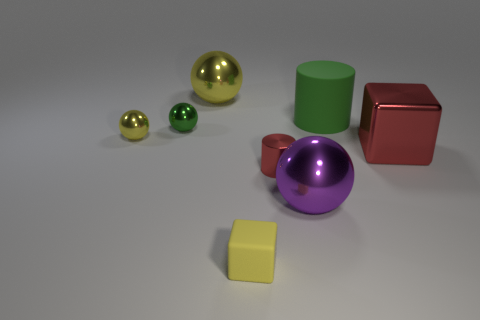Subtract 1 balls. How many balls are left? 3 Add 2 red metal objects. How many objects exist? 10 Subtract all blocks. How many objects are left? 6 Add 5 purple objects. How many purple objects are left? 6 Add 4 green things. How many green things exist? 6 Subtract 0 green cubes. How many objects are left? 8 Subtract all small blocks. Subtract all purple metallic spheres. How many objects are left? 6 